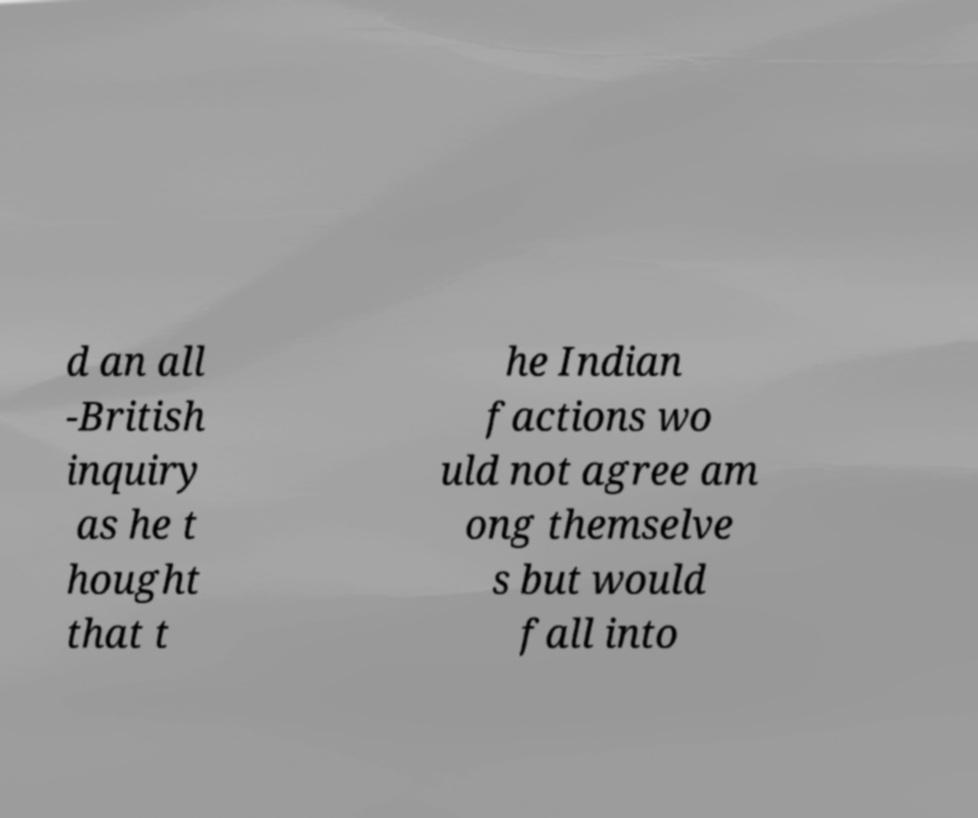There's text embedded in this image that I need extracted. Can you transcribe it verbatim? d an all -British inquiry as he t hought that t he Indian factions wo uld not agree am ong themselve s but would fall into 